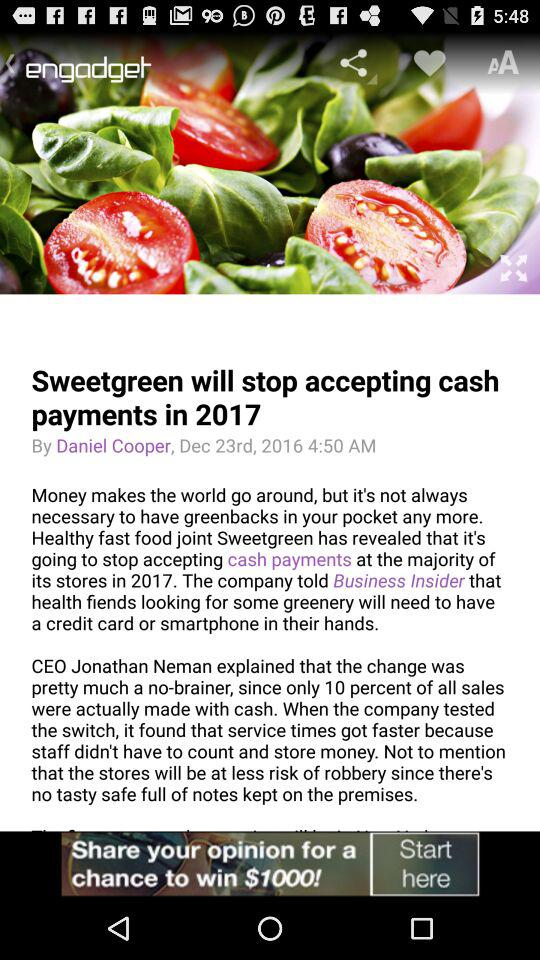What is the name of the author? The name of the author is Daniel Cooper. 